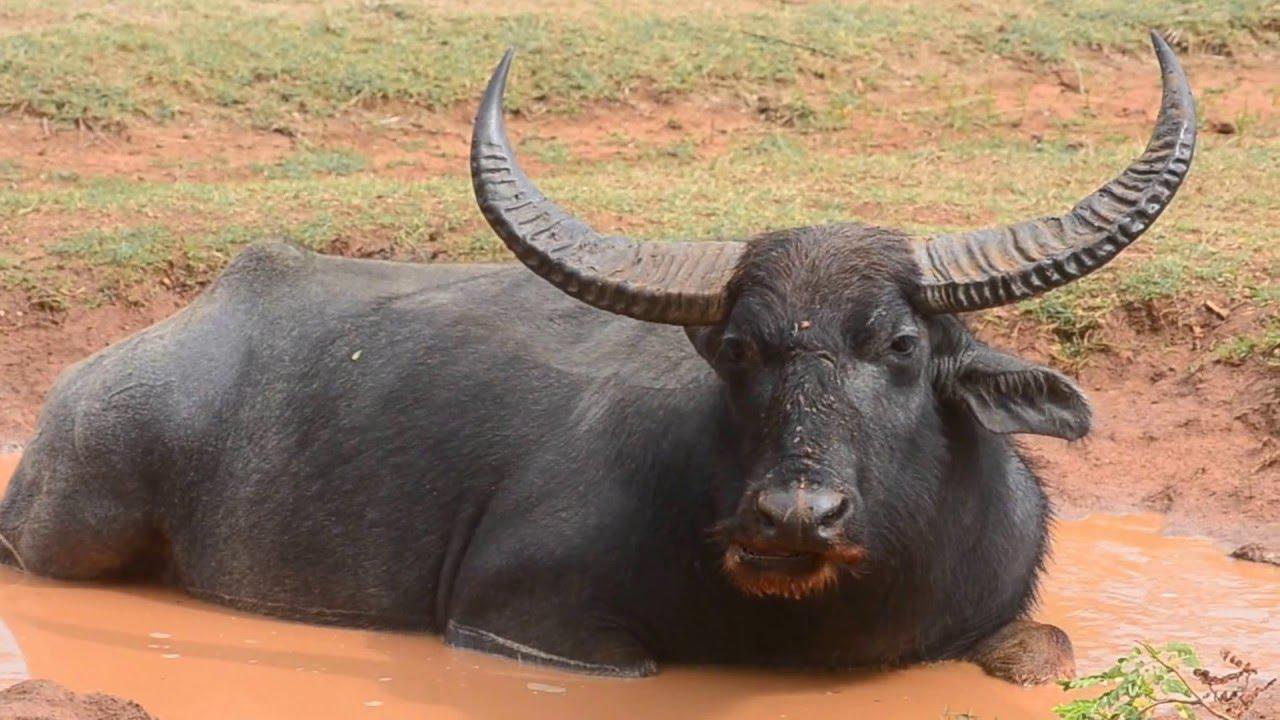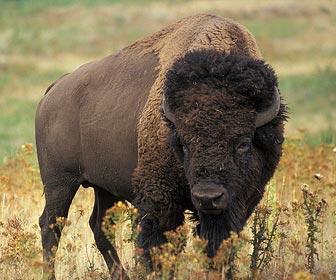The first image is the image on the left, the second image is the image on the right. Evaluate the accuracy of this statement regarding the images: "The left image shows a horned animal in water up to its chest, and the right image shows a buffalo on dry ground.". Is it true? Answer yes or no. Yes. 